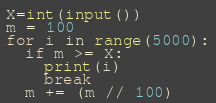Convert code to text. <code><loc_0><loc_0><loc_500><loc_500><_Python_>X=int(input())
m = 100
for i in range(5000):
  if m >= X:
    print(i)
    break
  m += (m // 100)
</code> 